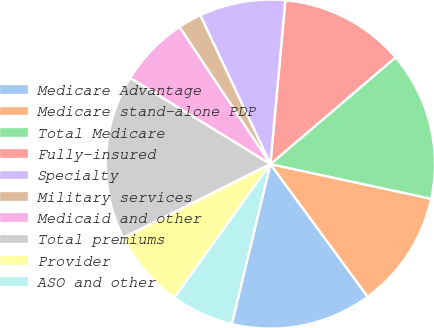Convert chart to OTSL. <chart><loc_0><loc_0><loc_500><loc_500><pie_chart><fcel>Medicare Advantage<fcel>Medicare stand-alone PDP<fcel>Total Medicare<fcel>Fully-insured<fcel>Specialty<fcel>Military services<fcel>Medicaid and other<fcel>Total premiums<fcel>Provider<fcel>ASO and other<nl><fcel>13.85%<fcel>11.54%<fcel>14.62%<fcel>12.31%<fcel>8.46%<fcel>2.31%<fcel>6.92%<fcel>16.15%<fcel>7.69%<fcel>6.15%<nl></chart> 